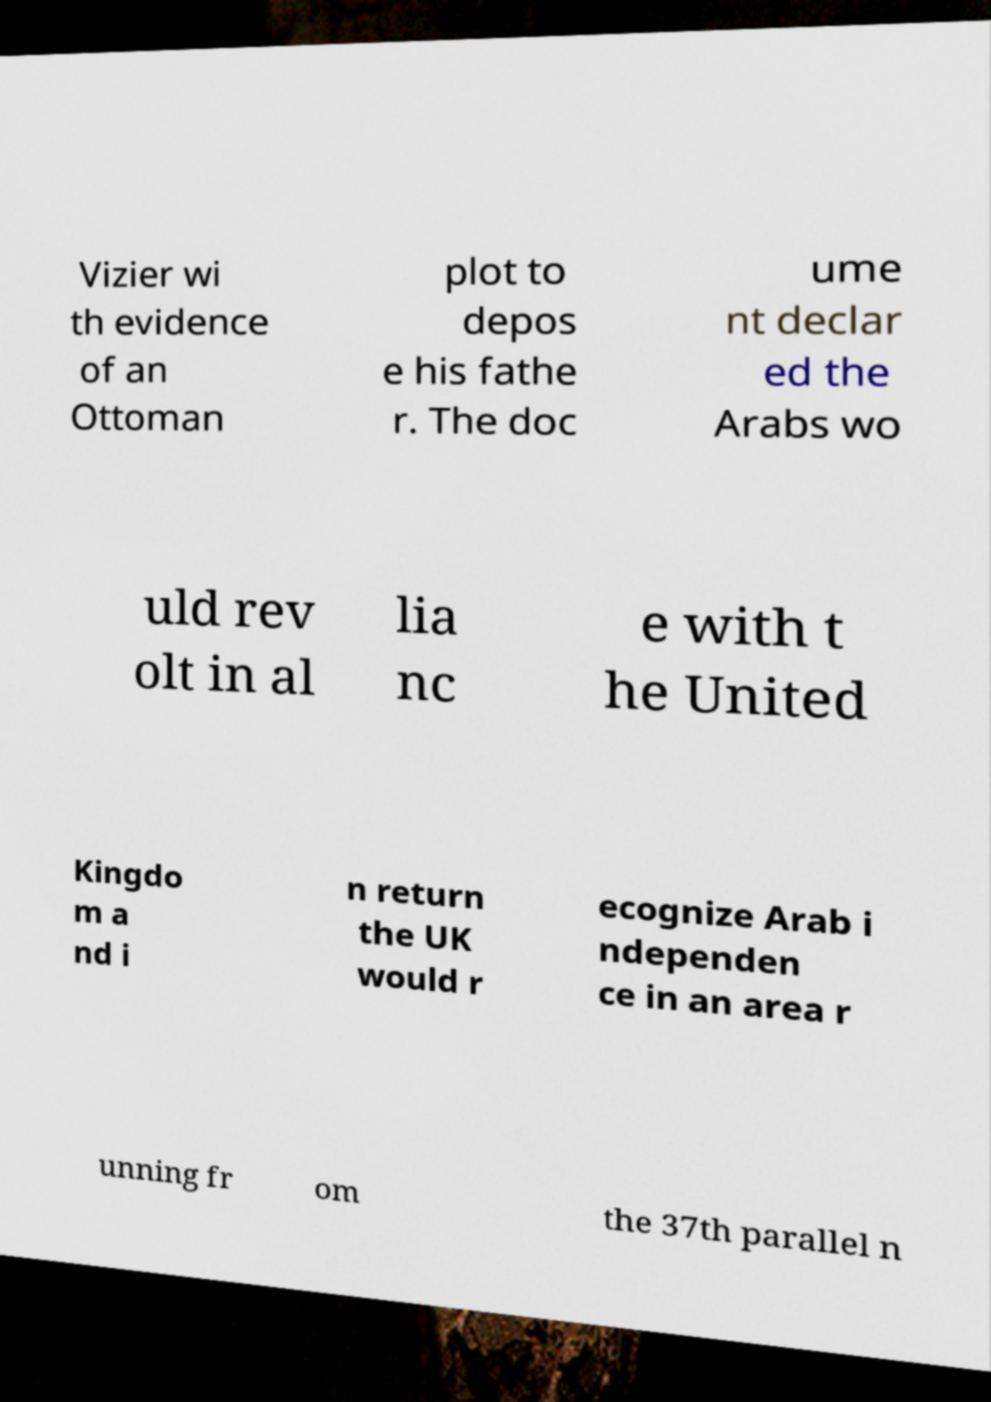There's text embedded in this image that I need extracted. Can you transcribe it verbatim? Vizier wi th evidence of an Ottoman plot to depos e his fathe r. The doc ume nt declar ed the Arabs wo uld rev olt in al lia nc e with t he United Kingdo m a nd i n return the UK would r ecognize Arab i ndependen ce in an area r unning fr om the 37th parallel n 